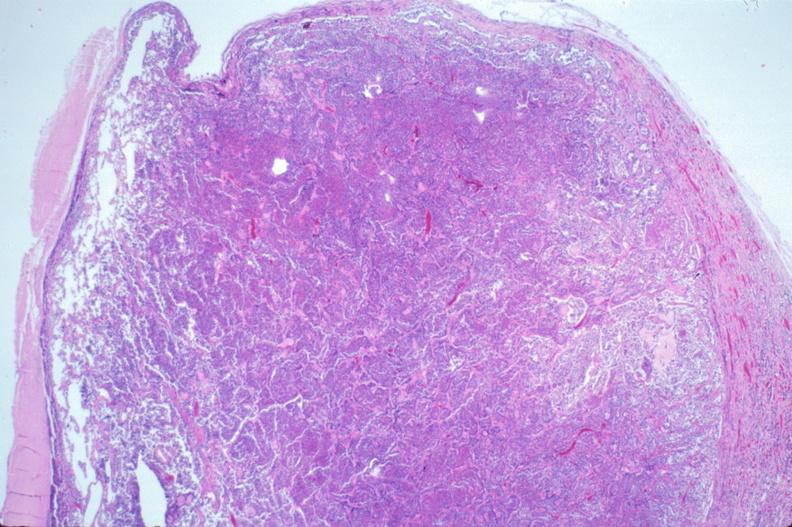s hemorrhage in newborn present?
Answer the question using a single word or phrase. No 